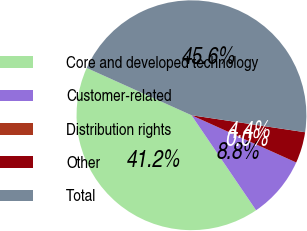<chart> <loc_0><loc_0><loc_500><loc_500><pie_chart><fcel>Core and developed technology<fcel>Customer-related<fcel>Distribution rights<fcel>Other<fcel>Total<nl><fcel>41.25%<fcel>8.75%<fcel>0.0%<fcel>4.38%<fcel>45.62%<nl></chart> 